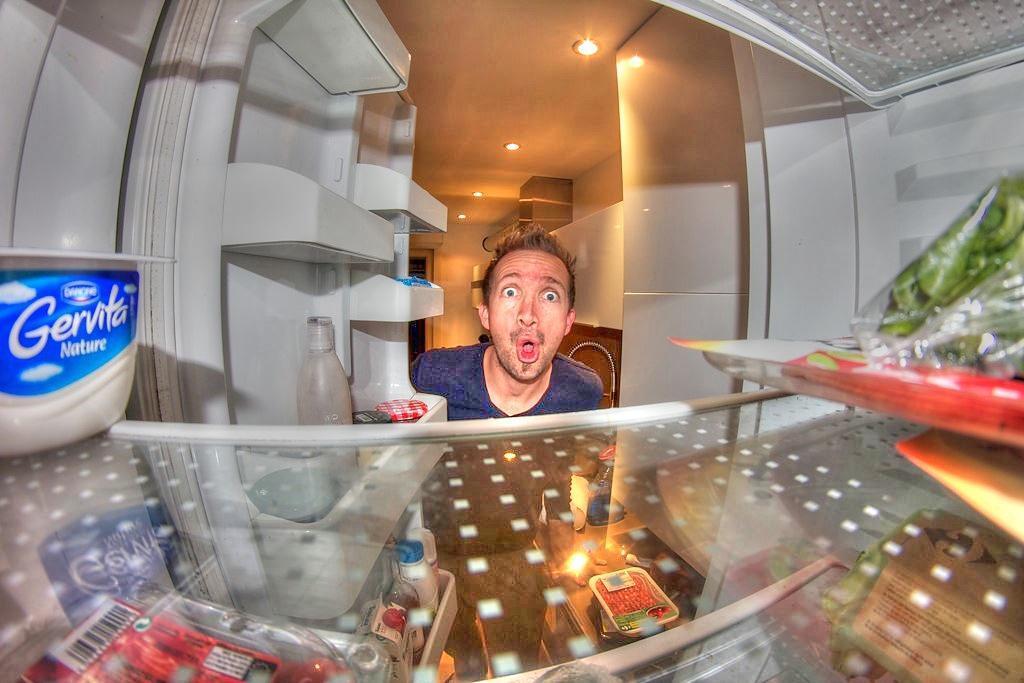In one or two sentences, can you explain what this image depicts? In this image there is an open fridge, a person, ceiling lights, bottle, food packets and objects. 